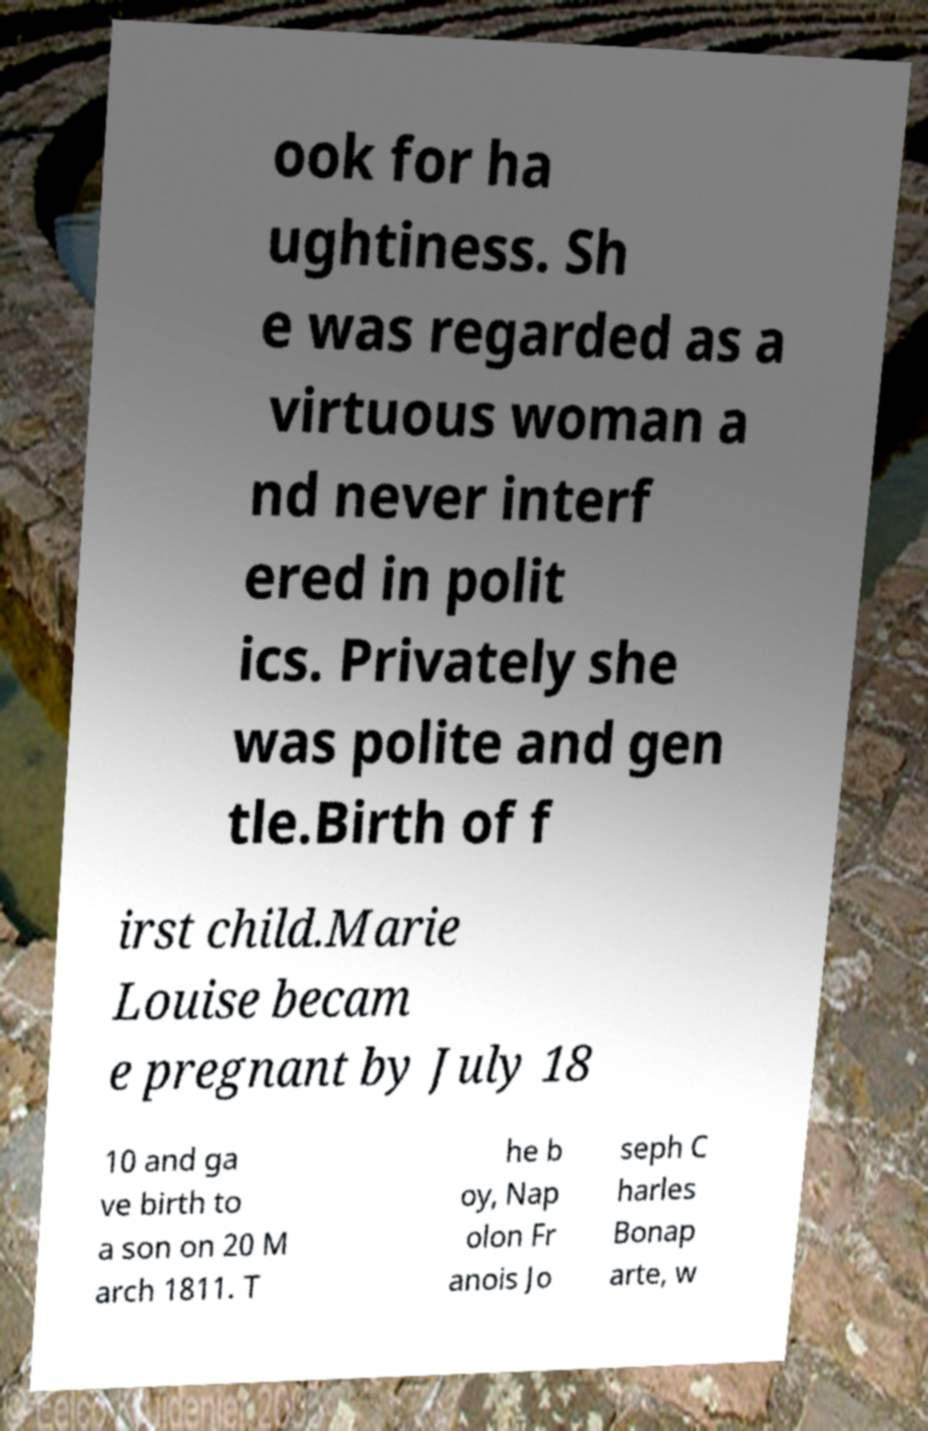What messages or text are displayed in this image? I need them in a readable, typed format. ook for ha ughtiness. Sh e was regarded as a virtuous woman a nd never interf ered in polit ics. Privately she was polite and gen tle.Birth of f irst child.Marie Louise becam e pregnant by July 18 10 and ga ve birth to a son on 20 M arch 1811. T he b oy, Nap olon Fr anois Jo seph C harles Bonap arte, w 